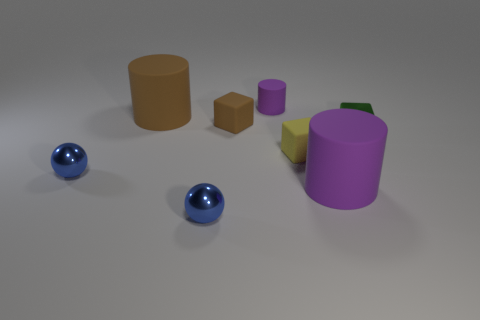Is there anything else that has the same color as the tiny metallic block?
Offer a terse response. No. What size is the purple rubber object right of the purple cylinder behind the green cube?
Provide a succinct answer. Large. Is the color of the large thing that is to the right of the tiny yellow block the same as the cylinder that is behind the big brown matte cylinder?
Make the answer very short. Yes. What color is the metal thing that is both to the right of the big brown matte cylinder and left of the tiny green shiny block?
Your response must be concise. Blue. What number of other things are there of the same shape as the big purple object?
Give a very brief answer. 2. What is the color of the cylinder that is the same size as the green shiny thing?
Your answer should be compact. Purple. What color is the big rubber object that is on the right side of the brown cube?
Give a very brief answer. Purple. Is there a big rubber object that is right of the cube that is in front of the tiny green thing?
Ensure brevity in your answer.  Yes. Do the large brown matte thing and the tiny purple thing behind the big purple thing have the same shape?
Provide a short and direct response. Yes. What is the size of the thing that is both in front of the yellow block and right of the tiny cylinder?
Offer a very short reply. Large. 